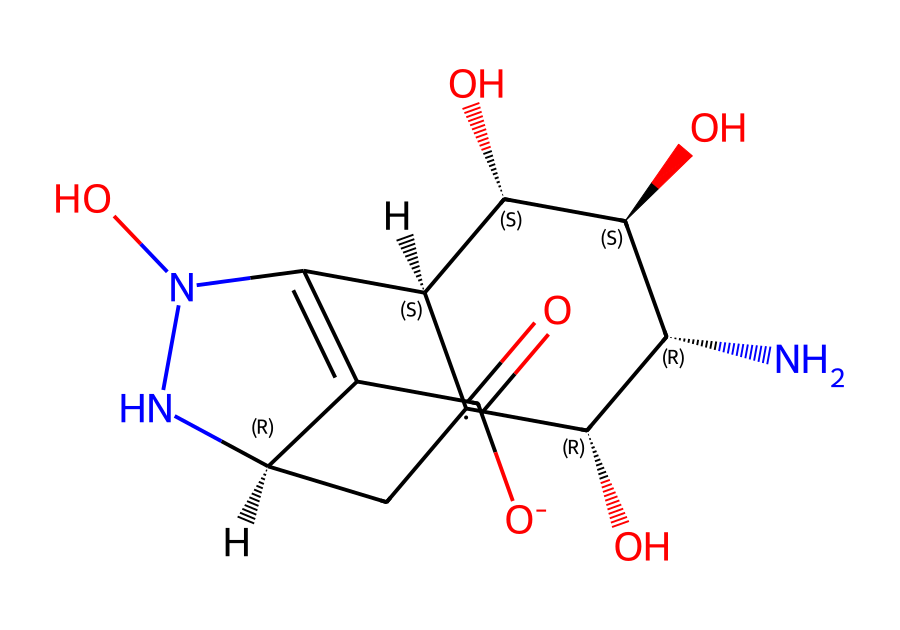What is the molecular formula of tetrodotoxin? To determine the molecular formula from the SMILES representation, we need to identify the distinct elements and count their occurrences. The analysis shows there are carbon (C), hydrogen (H), oxygen (O), and nitrogen (N) atoms present. By counting the atoms, the molecular formula can be derived as C11H17N3O8.
Answer: C11H17N3O8 How many nitrogen atoms are in tetrodotoxin? By examining the SMILES and identifying the nitrogen (N) symbols, we can ascertain the count. There are three nitrogen atoms indicated in the structure.
Answer: 3 What functional groups are present in tetrodotoxin? Looking closely at the chemical structure, we can identify various functional groups represented by specific arrangements of atoms. The presence of alcohol (hydroxyl groups) is indicated by the -OH, and the -C(=O)O- signifies a carboxylic acid group.
Answer: hydroxyl and carboxylic acid Is tetrodotoxin classified as a saturated or unsaturated compound? By analyzing the presence of double bonds in the structure, specifically within the -C=C- part of the backbone, we can conclude that tetrodotoxin contains such double bonds, signaling it as unsaturated.
Answer: unsaturated What role does the hydroxyl group play in tetrodotoxin's activity? The hydroxyl groups in tetrodotoxin are crucial for its interactions with biological receptors, specifically sodium channels in nerve cells, enhancing its neurotoxic properties through these functional interactions.
Answer: neurotoxic properties Which structure is most likely to interfere with ion channels? Analyzing the entire structure leads to identifying that the nitrogen atoms, particularly the ones within the cyclic portion of the molecule, are responsible for binding to voltage-gated sodium channels, making them a vital characteristic for interference in ion channel function.
Answer: nitrogen atoms How many total rings are present in the tetrodotoxin structure? Close observation of the rings within the chemical structure reveals two cyclic arrangements present. The structure indicates these rings contribute to the three-dimensional orientation and biological activity.
Answer: 2 